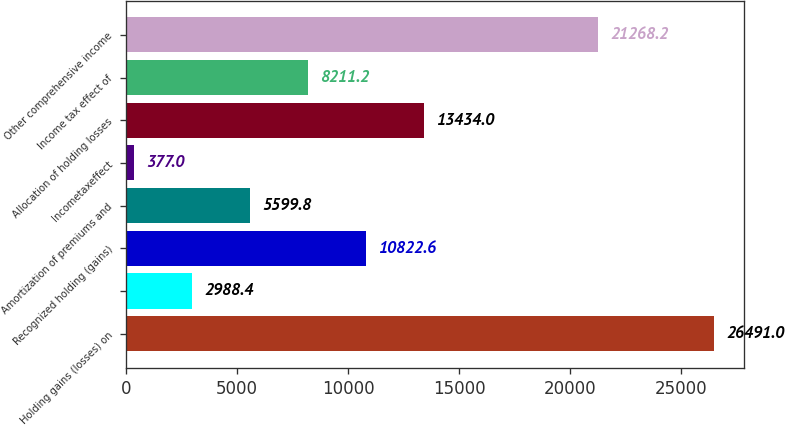Convert chart. <chart><loc_0><loc_0><loc_500><loc_500><bar_chart><fcel>Holding gains (losses) on<fcel>Unnamed: 1<fcel>Recognized holding (gains)<fcel>Amortization of premiums and<fcel>Incometaxeffect<fcel>Allocation of holding losses<fcel>Income tax effect of<fcel>Other comprehensive income<nl><fcel>26491<fcel>2988.4<fcel>10822.6<fcel>5599.8<fcel>377<fcel>13434<fcel>8211.2<fcel>21268.2<nl></chart> 